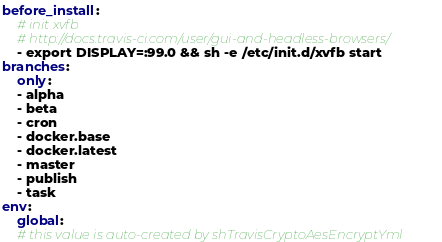Convert code to text. <code><loc_0><loc_0><loc_500><loc_500><_YAML_>before_install:
    # init xvfb
    # http://docs.travis-ci.com/user/gui-and-headless-browsers/
    - export DISPLAY=:99.0 && sh -e /etc/init.d/xvfb start
branches:
    only:
    - alpha
    - beta
    - cron
    - docker.base
    - docker.latest
    - master
    - publish
    - task
env:
    global:
    # this value is auto-created by shTravisCryptoAesEncryptYml</code> 